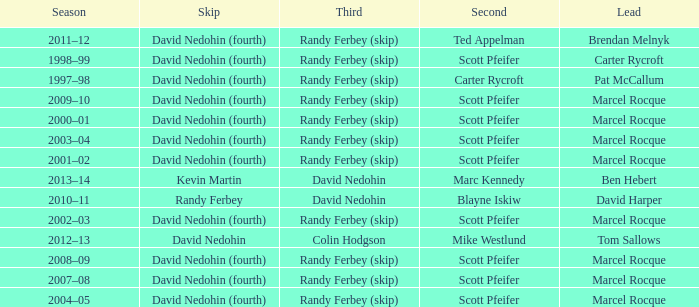Which Skip has a Season of 2002–03? David Nedohin (fourth). 